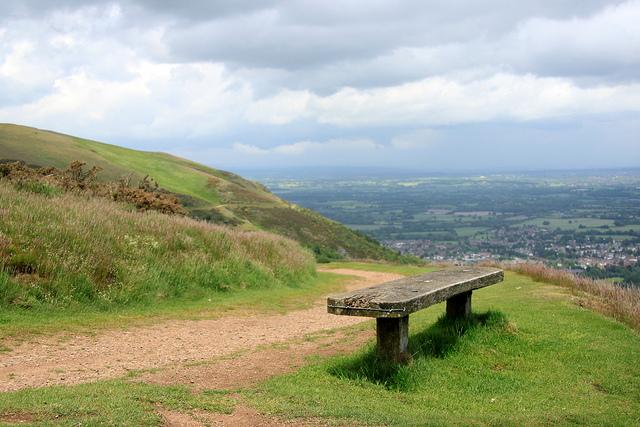How many people are sitting on the bench?
Give a very brief answer. 0. What side of the picture is the valley on?
Concise answer only. Right. Is it overcast?
Quick response, please. Yes. What color is the bench on the side of the hill?
Write a very short answer. Brown. Are any living creatures present?
Quick response, please. No. 